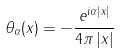<formula> <loc_0><loc_0><loc_500><loc_500>\theta _ { \alpha } ( x ) = - \frac { e ^ { i \alpha \left | x \right | } } { 4 \pi \left | x \right | }</formula> 